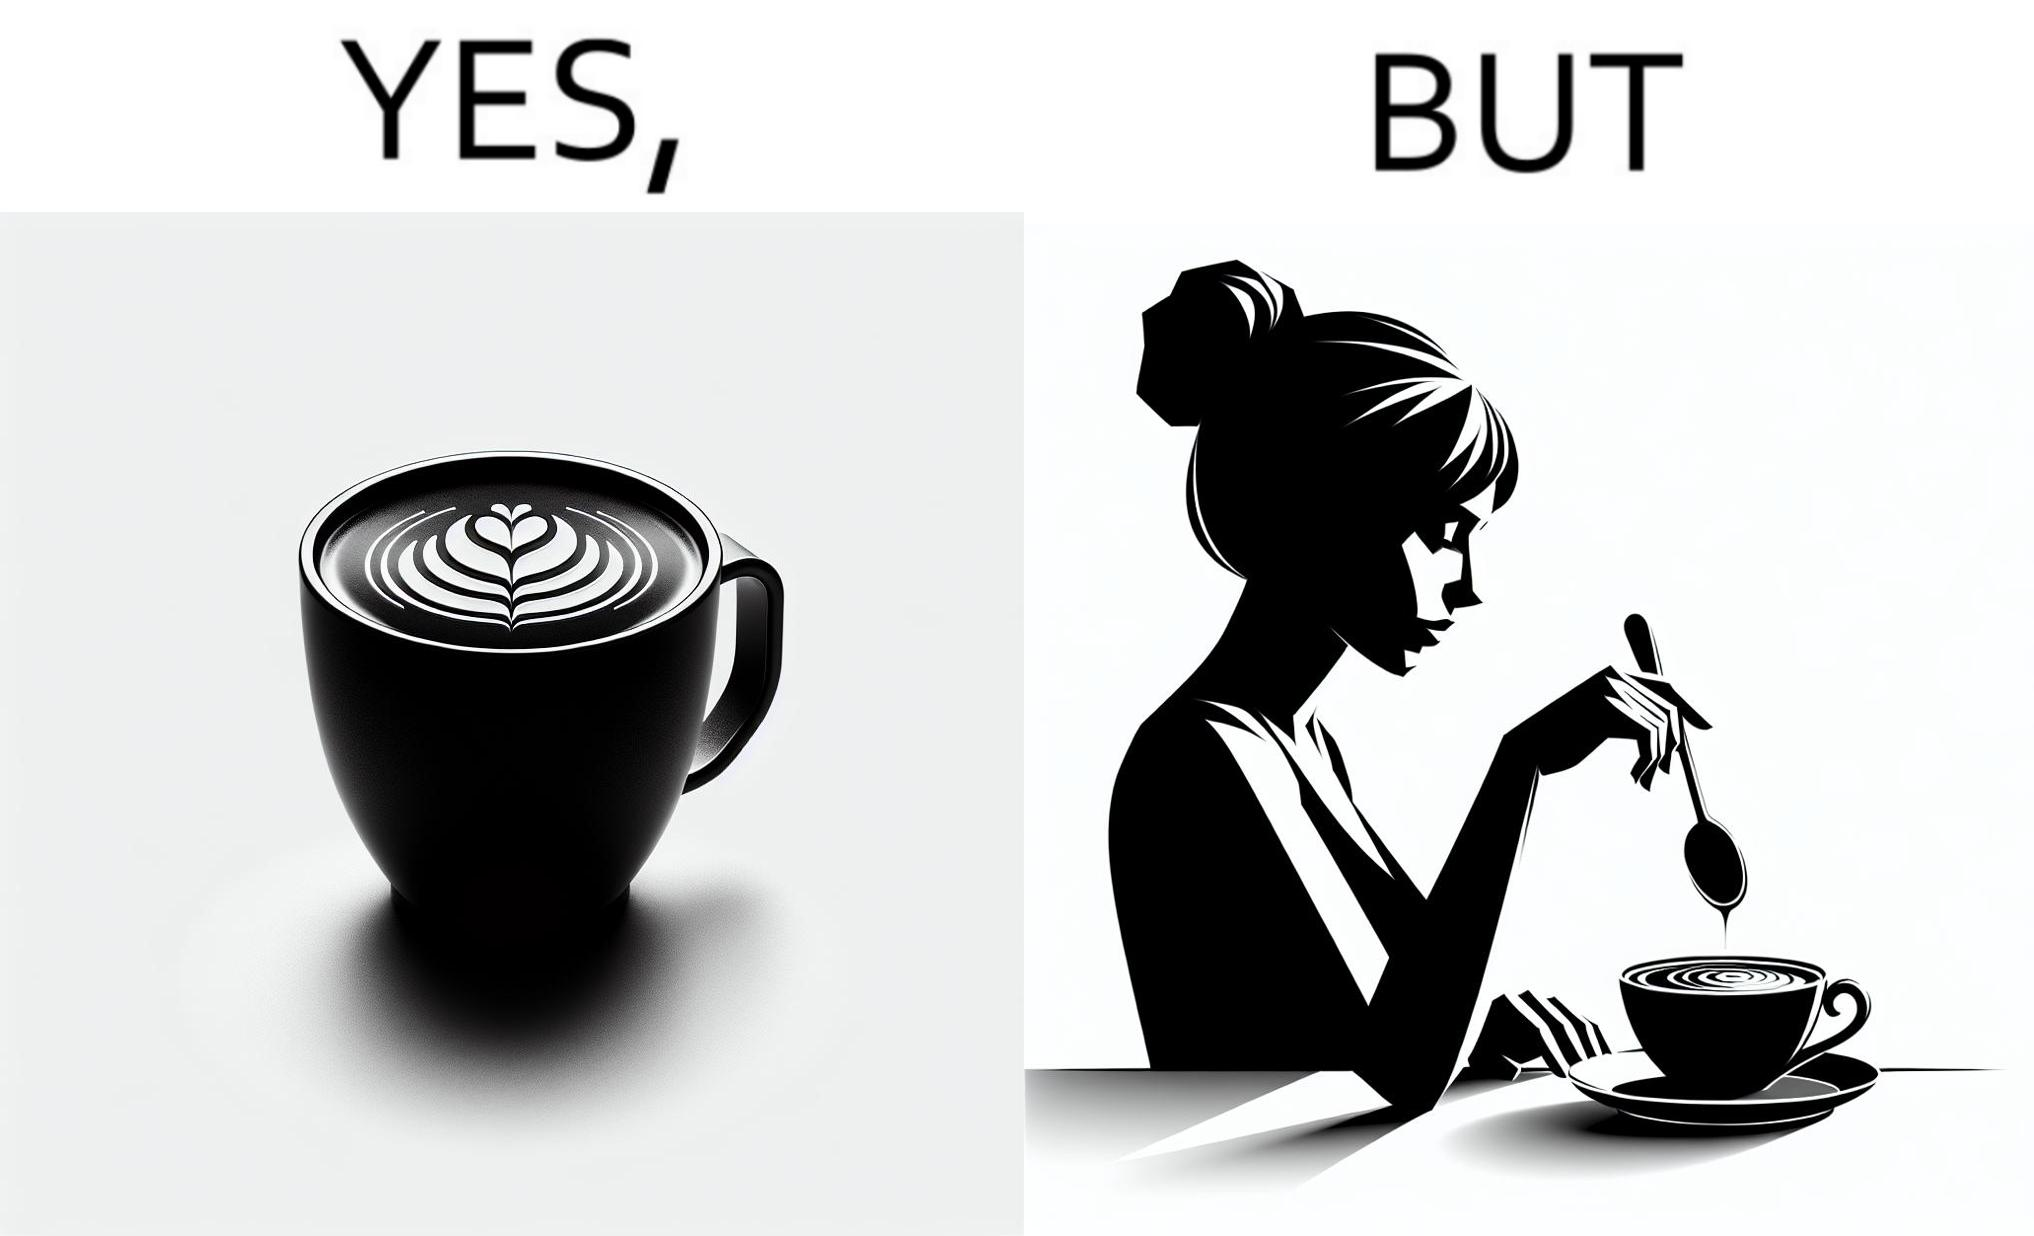Explain why this image is satirical. The image is ironic, because even when the coffee maker create latte art to make coffee look attractive but it is there just for a short time after that it is vanished 